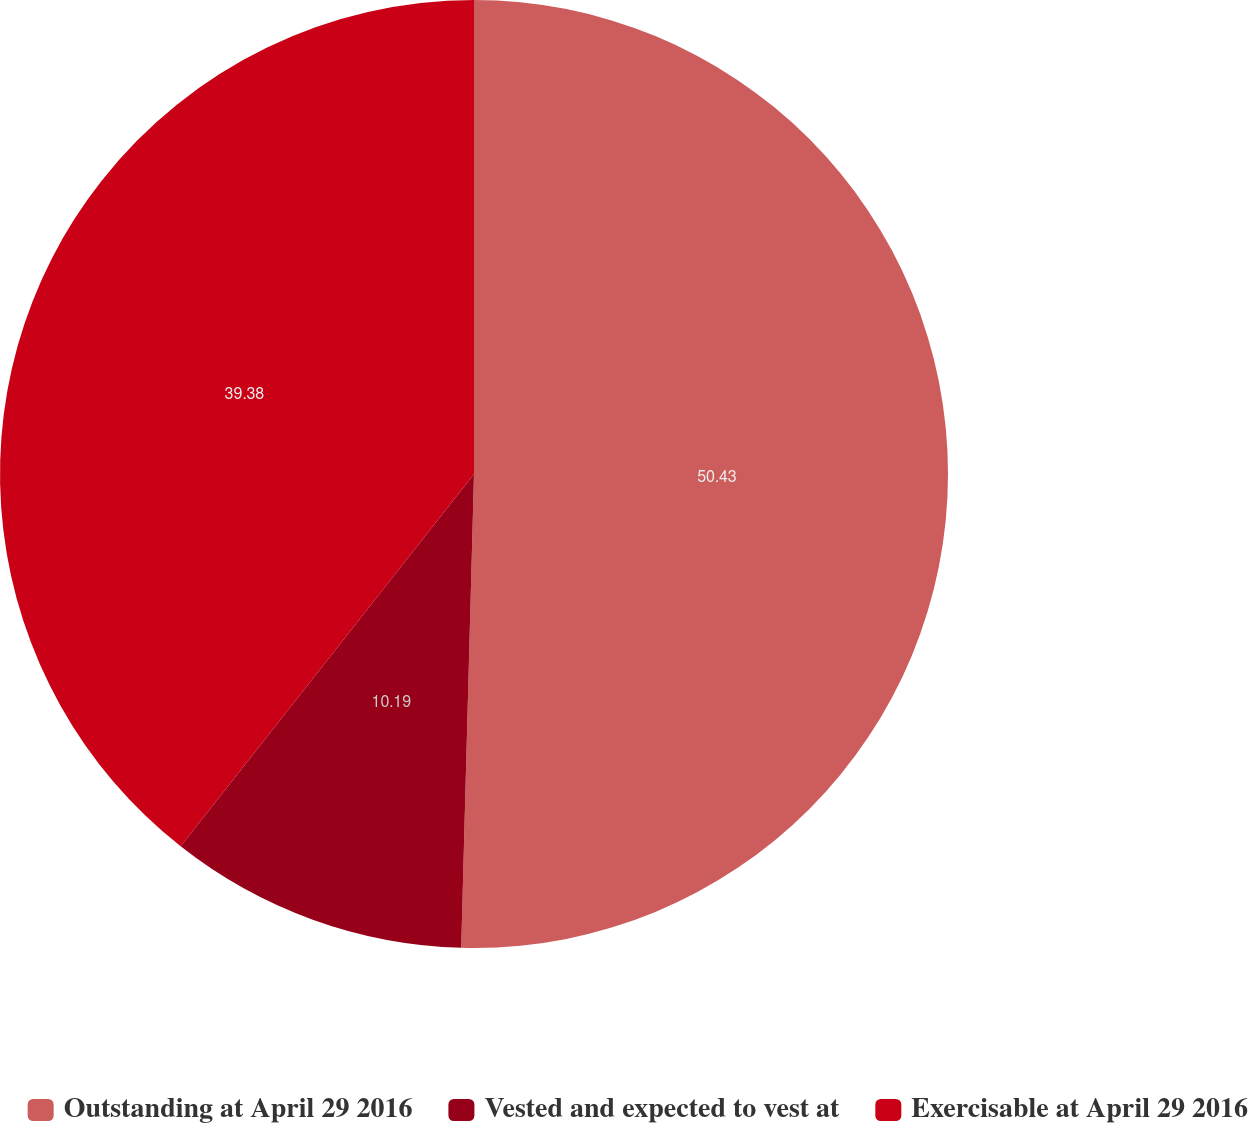Convert chart to OTSL. <chart><loc_0><loc_0><loc_500><loc_500><pie_chart><fcel>Outstanding at April 29 2016<fcel>Vested and expected to vest at<fcel>Exercisable at April 29 2016<nl><fcel>50.43%<fcel>10.19%<fcel>39.38%<nl></chart> 